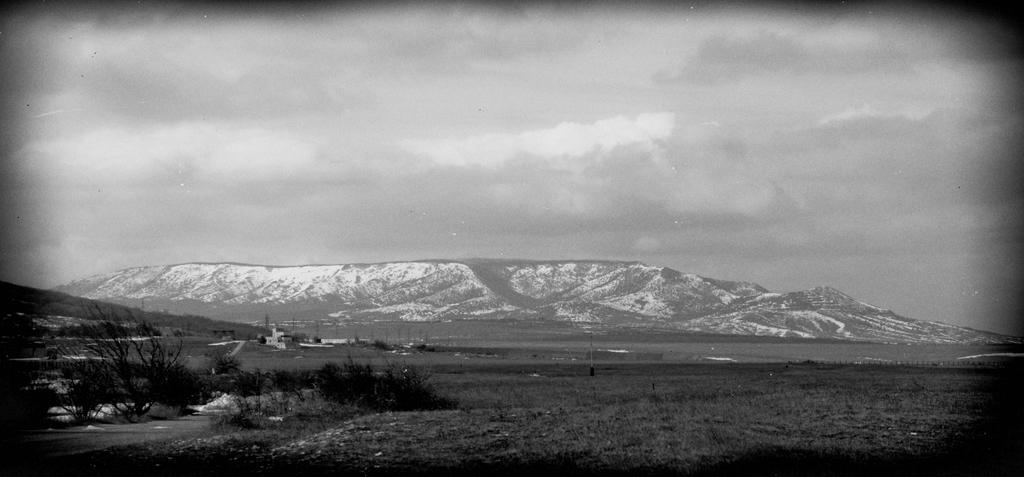What is the color scheme of the image? The image is black and white. What type of landscape can be seen in the image? There is a field in the image. What other natural elements are present in the image? There are trees and hills in the image. What can be seen in the background of the image? The sky is visible in the background of the image. Where is the quiver located in the image? There is no quiver present in the image. Can you see a nest in the trees in the image? The image is in black and white, so it is not possible to determine if there is a nest in the trees. Is there a boy visible in the image? There is no boy present in the image. 